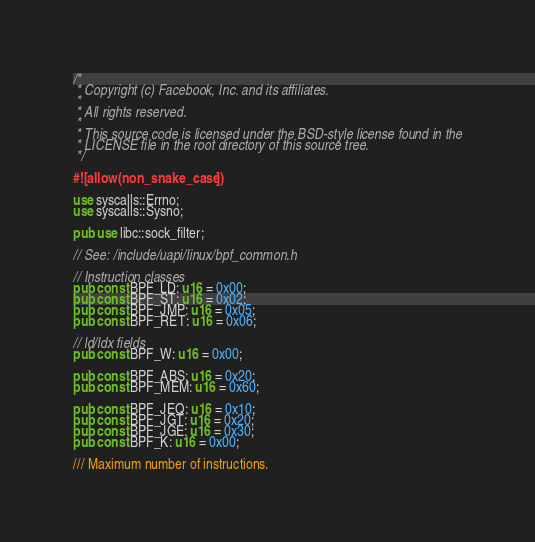<code> <loc_0><loc_0><loc_500><loc_500><_Rust_>/*
 * Copyright (c) Facebook, Inc. and its affiliates.
 *
 * All rights reserved.
 *
 * This source code is licensed under the BSD-style license found in the
 * LICENSE file in the root directory of this source tree.
 */

#![allow(non_snake_case)]

use syscalls::Errno;
use syscalls::Sysno;

pub use libc::sock_filter;

// See: /include/uapi/linux/bpf_common.h

// Instruction classes
pub const BPF_LD: u16 = 0x00;
pub const BPF_ST: u16 = 0x02;
pub const BPF_JMP: u16 = 0x05;
pub const BPF_RET: u16 = 0x06;

// ld/ldx fields
pub const BPF_W: u16 = 0x00;

pub const BPF_ABS: u16 = 0x20;
pub const BPF_MEM: u16 = 0x60;

pub const BPF_JEQ: u16 = 0x10;
pub const BPF_JGT: u16 = 0x20;
pub const BPF_JGE: u16 = 0x30;
pub const BPF_K: u16 = 0x00;

/// Maximum number of instructions.</code> 